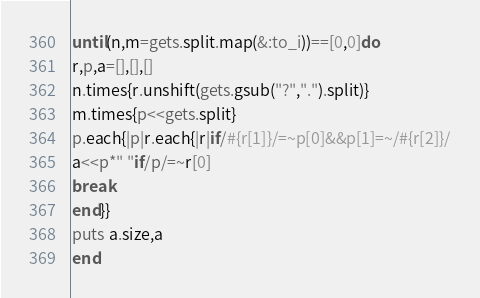Convert code to text. <code><loc_0><loc_0><loc_500><loc_500><_Ruby_>until(n,m=gets.split.map(&:to_i))==[0,0]do
r,p,a=[],[],[]
n.times{r.unshift(gets.gsub("?",".").split)}
m.times{p<<gets.split}
p.each{|p|r.each{|r|if/#{r[1]}/=~p[0]&&p[1]=~/#{r[2]}/
a<<p*" "if/p/=~r[0]
break
end}}
puts a.size,a
end</code> 